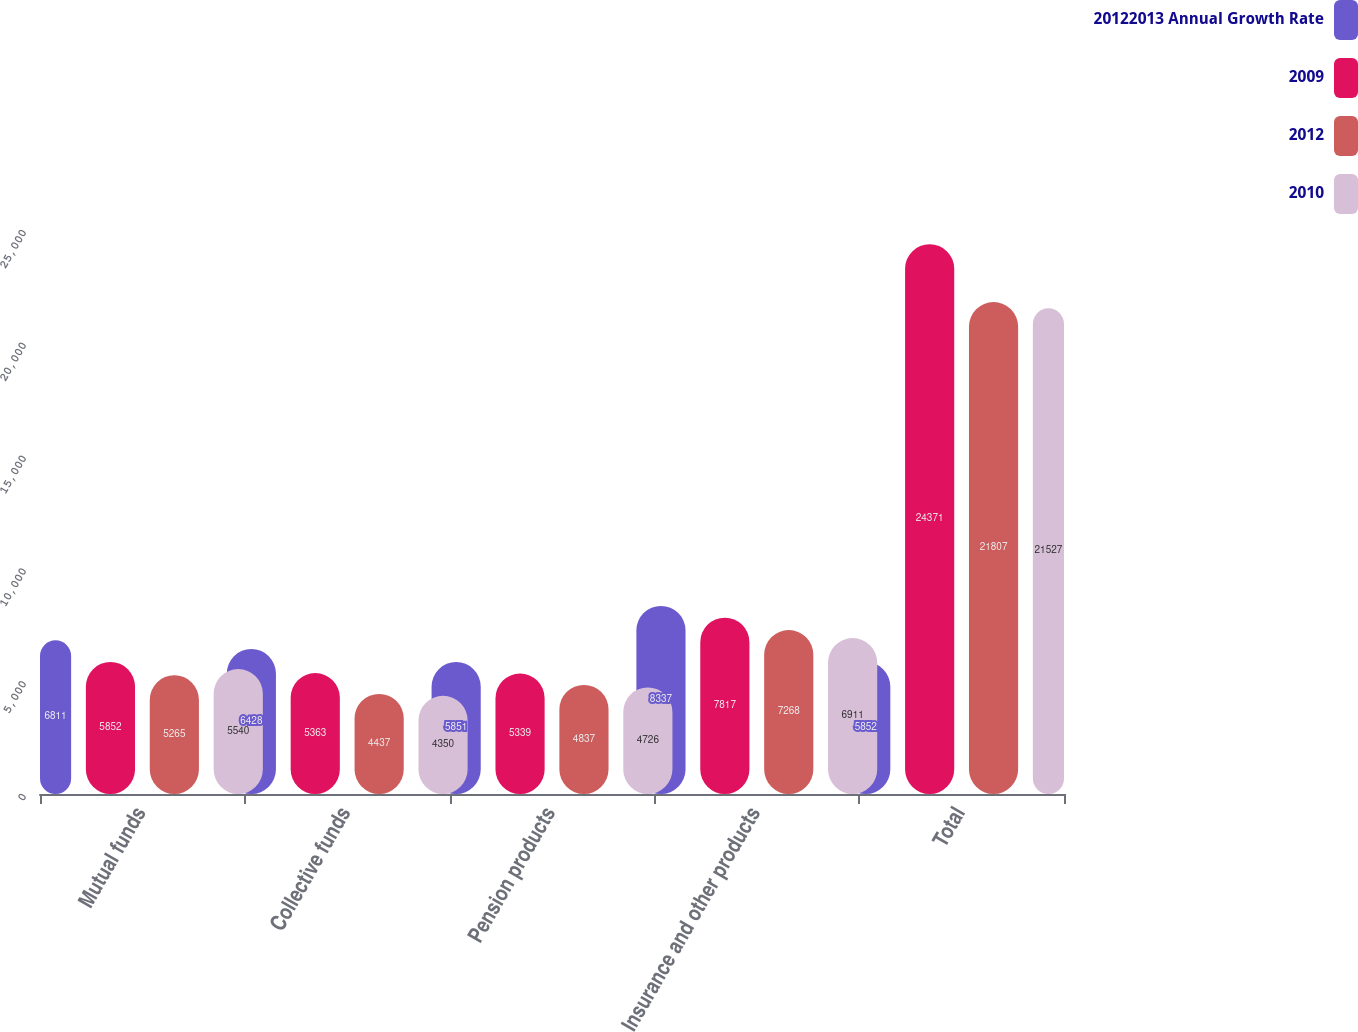Convert chart to OTSL. <chart><loc_0><loc_0><loc_500><loc_500><stacked_bar_chart><ecel><fcel>Mutual funds<fcel>Collective funds<fcel>Pension products<fcel>Insurance and other products<fcel>Total<nl><fcel>20122013 Annual Growth Rate<fcel>6811<fcel>6428<fcel>5851<fcel>8337<fcel>5852<nl><fcel>2009<fcel>5852<fcel>5363<fcel>5339<fcel>7817<fcel>24371<nl><fcel>2012<fcel>5265<fcel>4437<fcel>4837<fcel>7268<fcel>21807<nl><fcel>2010<fcel>5540<fcel>4350<fcel>4726<fcel>6911<fcel>21527<nl></chart> 